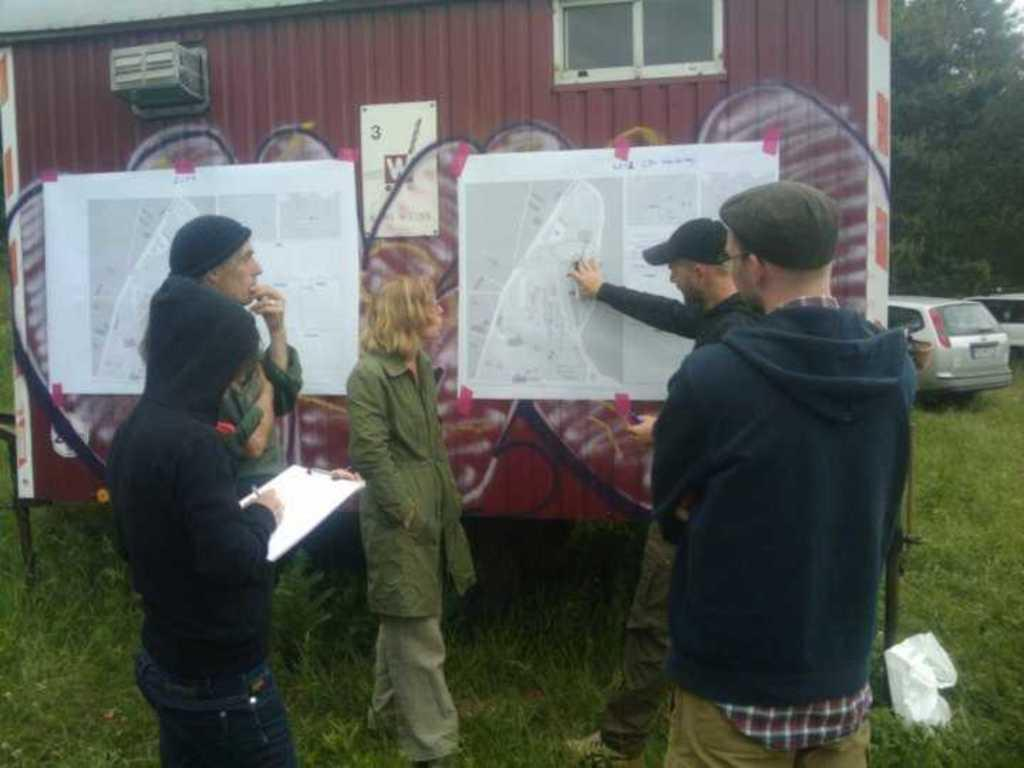How many people are present in the image? There are five people standing in the image. What is located in the middle of the image? There is a vehicle in the middle of the image. What is attached to the vehicle? Pipes are attached to the vehicle. What can be seen in the background of the image? There are cars and trees in the background of the image. What type of rifle is being used by the organization in the image? There is no rifle or organization present in the image. What is the thing that the people are holding in the image? The provided facts do not mention any specific objects being held by the people in the image. 